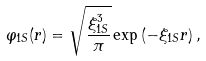Convert formula to latex. <formula><loc_0><loc_0><loc_500><loc_500>\varphi _ { 1 S } ( r ) = \sqrt { \frac { \xi _ { 1 S } ^ { 3 } } { \pi } } \exp \left ( - \xi _ { 1 S } r \right ) ,</formula> 